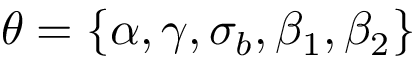Convert formula to latex. <formula><loc_0><loc_0><loc_500><loc_500>\theta = \{ \alpha , \gamma , \sigma _ { b } , \beta _ { 1 } , \beta _ { 2 } \}</formula> 